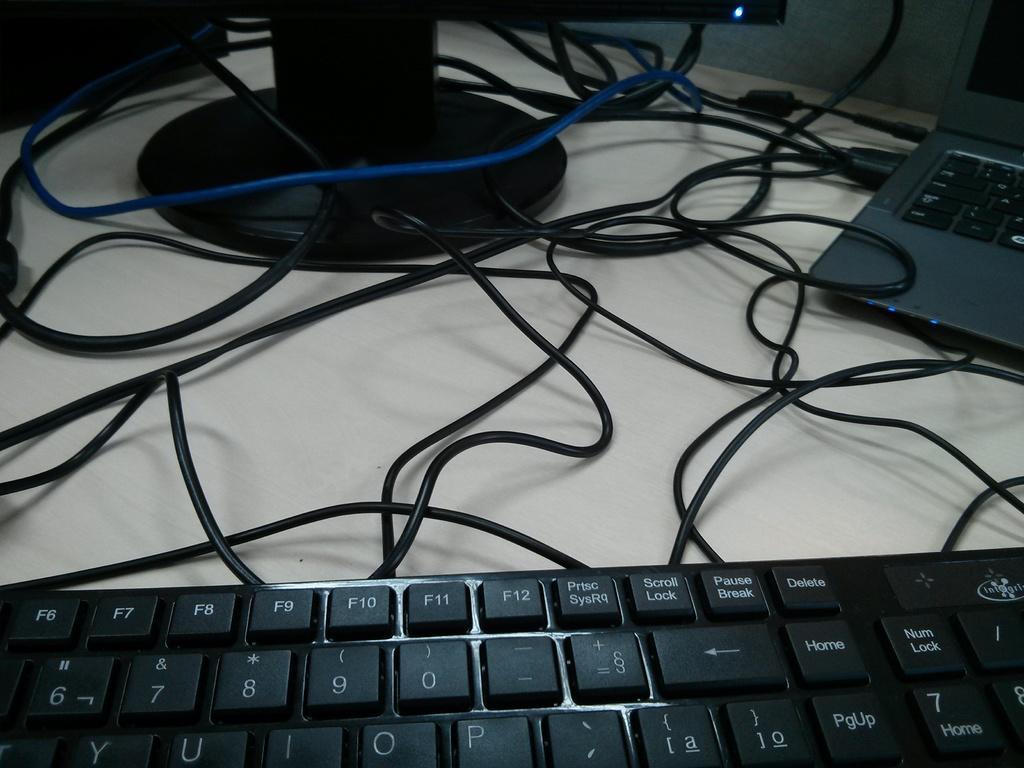Can you describe this image briefly? In this image we can see a keyboard, a laptop, system and few wires on the table and a wall in the background. 